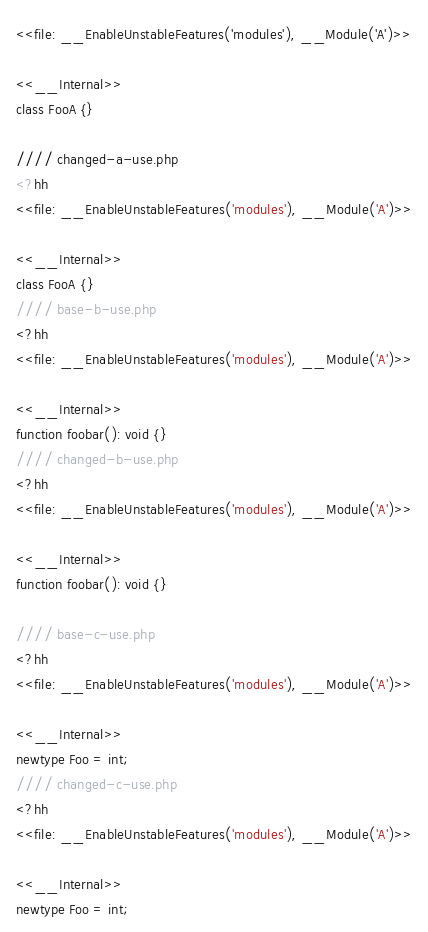Convert code to text. <code><loc_0><loc_0><loc_500><loc_500><_PHP_><<file: __EnableUnstableFeatures('modules'), __Module('A')>>

<<__Internal>>
class FooA {}

//// changed-a-use.php
<?hh
<<file: __EnableUnstableFeatures('modules'), __Module('A')>>

<<__Internal>>
class FooA {}
//// base-b-use.php
<?hh
<<file: __EnableUnstableFeatures('modules'), __Module('A')>>

<<__Internal>>
function foobar(): void {}
//// changed-b-use.php
<?hh
<<file: __EnableUnstableFeatures('modules'), __Module('A')>>

<<__Internal>>
function foobar(): void {}

//// base-c-use.php
<?hh
<<file: __EnableUnstableFeatures('modules'), __Module('A')>>

<<__Internal>>
newtype Foo = int;
//// changed-c-use.php
<?hh
<<file: __EnableUnstableFeatures('modules'), __Module('A')>>

<<__Internal>>
newtype Foo = int;
</code> 